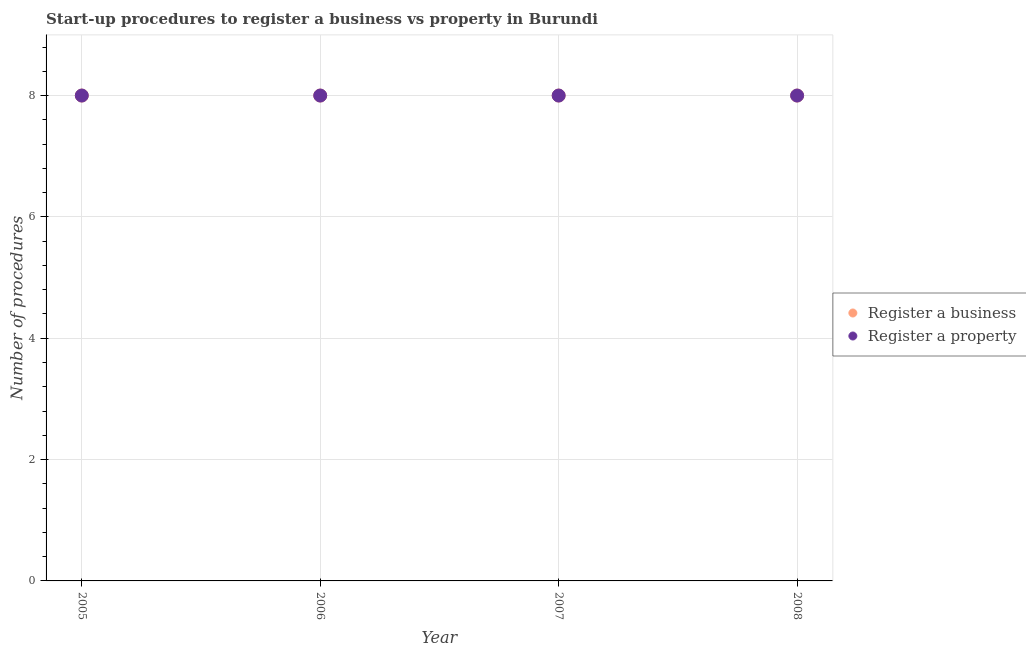Is the number of dotlines equal to the number of legend labels?
Make the answer very short. Yes. What is the number of procedures to register a business in 2008?
Offer a very short reply. 8. Across all years, what is the maximum number of procedures to register a property?
Your answer should be compact. 8. Across all years, what is the minimum number of procedures to register a property?
Provide a succinct answer. 8. What is the total number of procedures to register a business in the graph?
Ensure brevity in your answer.  32. In the year 2006, what is the difference between the number of procedures to register a property and number of procedures to register a business?
Your answer should be very brief. 0. In how many years, is the number of procedures to register a business greater than 2.4?
Your answer should be very brief. 4. What is the ratio of the number of procedures to register a business in 2005 to that in 2007?
Provide a succinct answer. 1. Is the difference between the number of procedures to register a business in 2005 and 2008 greater than the difference between the number of procedures to register a property in 2005 and 2008?
Provide a succinct answer. No. What is the difference between the highest and the second highest number of procedures to register a business?
Provide a short and direct response. 0. In how many years, is the number of procedures to register a business greater than the average number of procedures to register a business taken over all years?
Your answer should be compact. 0. Is the sum of the number of procedures to register a business in 2005 and 2006 greater than the maximum number of procedures to register a property across all years?
Offer a terse response. Yes. Does the number of procedures to register a property monotonically increase over the years?
Your answer should be very brief. No. How many years are there in the graph?
Offer a very short reply. 4. Where does the legend appear in the graph?
Provide a short and direct response. Center right. What is the title of the graph?
Give a very brief answer. Start-up procedures to register a business vs property in Burundi. Does "Birth rate" appear as one of the legend labels in the graph?
Offer a terse response. No. What is the label or title of the X-axis?
Offer a terse response. Year. What is the label or title of the Y-axis?
Offer a very short reply. Number of procedures. What is the Number of procedures of Register a business in 2006?
Offer a very short reply. 8. What is the Number of procedures in Register a business in 2007?
Your response must be concise. 8. What is the Number of procedures of Register a property in 2007?
Ensure brevity in your answer.  8. What is the Number of procedures in Register a business in 2008?
Give a very brief answer. 8. What is the Number of procedures in Register a property in 2008?
Your response must be concise. 8. Across all years, what is the maximum Number of procedures in Register a property?
Keep it short and to the point. 8. Across all years, what is the minimum Number of procedures in Register a business?
Make the answer very short. 8. What is the total Number of procedures of Register a property in the graph?
Your response must be concise. 32. What is the difference between the Number of procedures in Register a property in 2005 and that in 2006?
Offer a terse response. 0. What is the difference between the Number of procedures of Register a business in 2005 and that in 2007?
Your answer should be very brief. 0. What is the difference between the Number of procedures in Register a property in 2005 and that in 2007?
Make the answer very short. 0. What is the difference between the Number of procedures in Register a business in 2005 and that in 2008?
Give a very brief answer. 0. What is the difference between the Number of procedures of Register a property in 2005 and that in 2008?
Ensure brevity in your answer.  0. What is the difference between the Number of procedures of Register a business in 2006 and that in 2007?
Offer a very short reply. 0. What is the difference between the Number of procedures in Register a property in 2006 and that in 2008?
Provide a short and direct response. 0. What is the difference between the Number of procedures in Register a property in 2007 and that in 2008?
Your answer should be very brief. 0. What is the difference between the Number of procedures in Register a business in 2005 and the Number of procedures in Register a property in 2007?
Offer a terse response. 0. What is the difference between the Number of procedures in Register a business in 2006 and the Number of procedures in Register a property in 2007?
Keep it short and to the point. 0. What is the difference between the Number of procedures in Register a business in 2007 and the Number of procedures in Register a property in 2008?
Ensure brevity in your answer.  0. In the year 2006, what is the difference between the Number of procedures in Register a business and Number of procedures in Register a property?
Make the answer very short. 0. In the year 2007, what is the difference between the Number of procedures in Register a business and Number of procedures in Register a property?
Make the answer very short. 0. In the year 2008, what is the difference between the Number of procedures in Register a business and Number of procedures in Register a property?
Offer a terse response. 0. What is the ratio of the Number of procedures of Register a business in 2005 to that in 2006?
Provide a short and direct response. 1. What is the ratio of the Number of procedures of Register a property in 2005 to that in 2008?
Your answer should be very brief. 1. What is the ratio of the Number of procedures in Register a property in 2006 to that in 2008?
Ensure brevity in your answer.  1. What is the difference between the highest and the second highest Number of procedures of Register a business?
Your response must be concise. 0. What is the difference between the highest and the lowest Number of procedures in Register a property?
Your response must be concise. 0. 